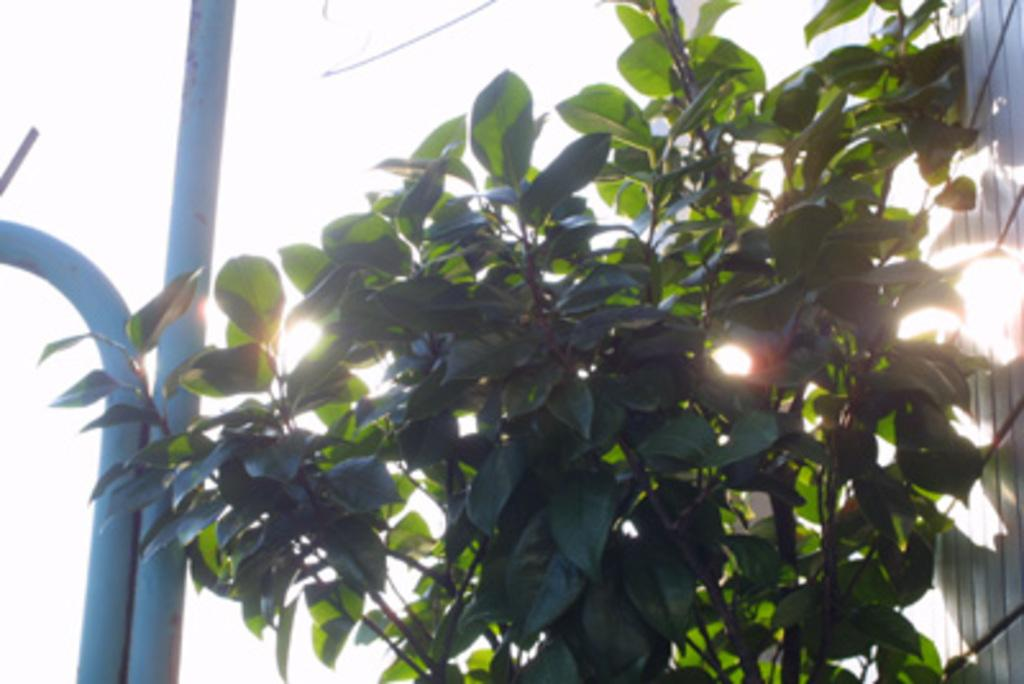What type of living organisms can be seen in the image? Plants can be seen in the image. Where are the plants located in relation to other objects? The plants are placed near pipes and a wall. What can be seen in the image that indicates the presence of sunlight? Sunbeams are visible in the image. Can the sky be seen in the image? The sky might be present at the top of the image, but it is not explicitly mentioned in the facts. What size of boot is visible in the image? There is no boot present in the image. 